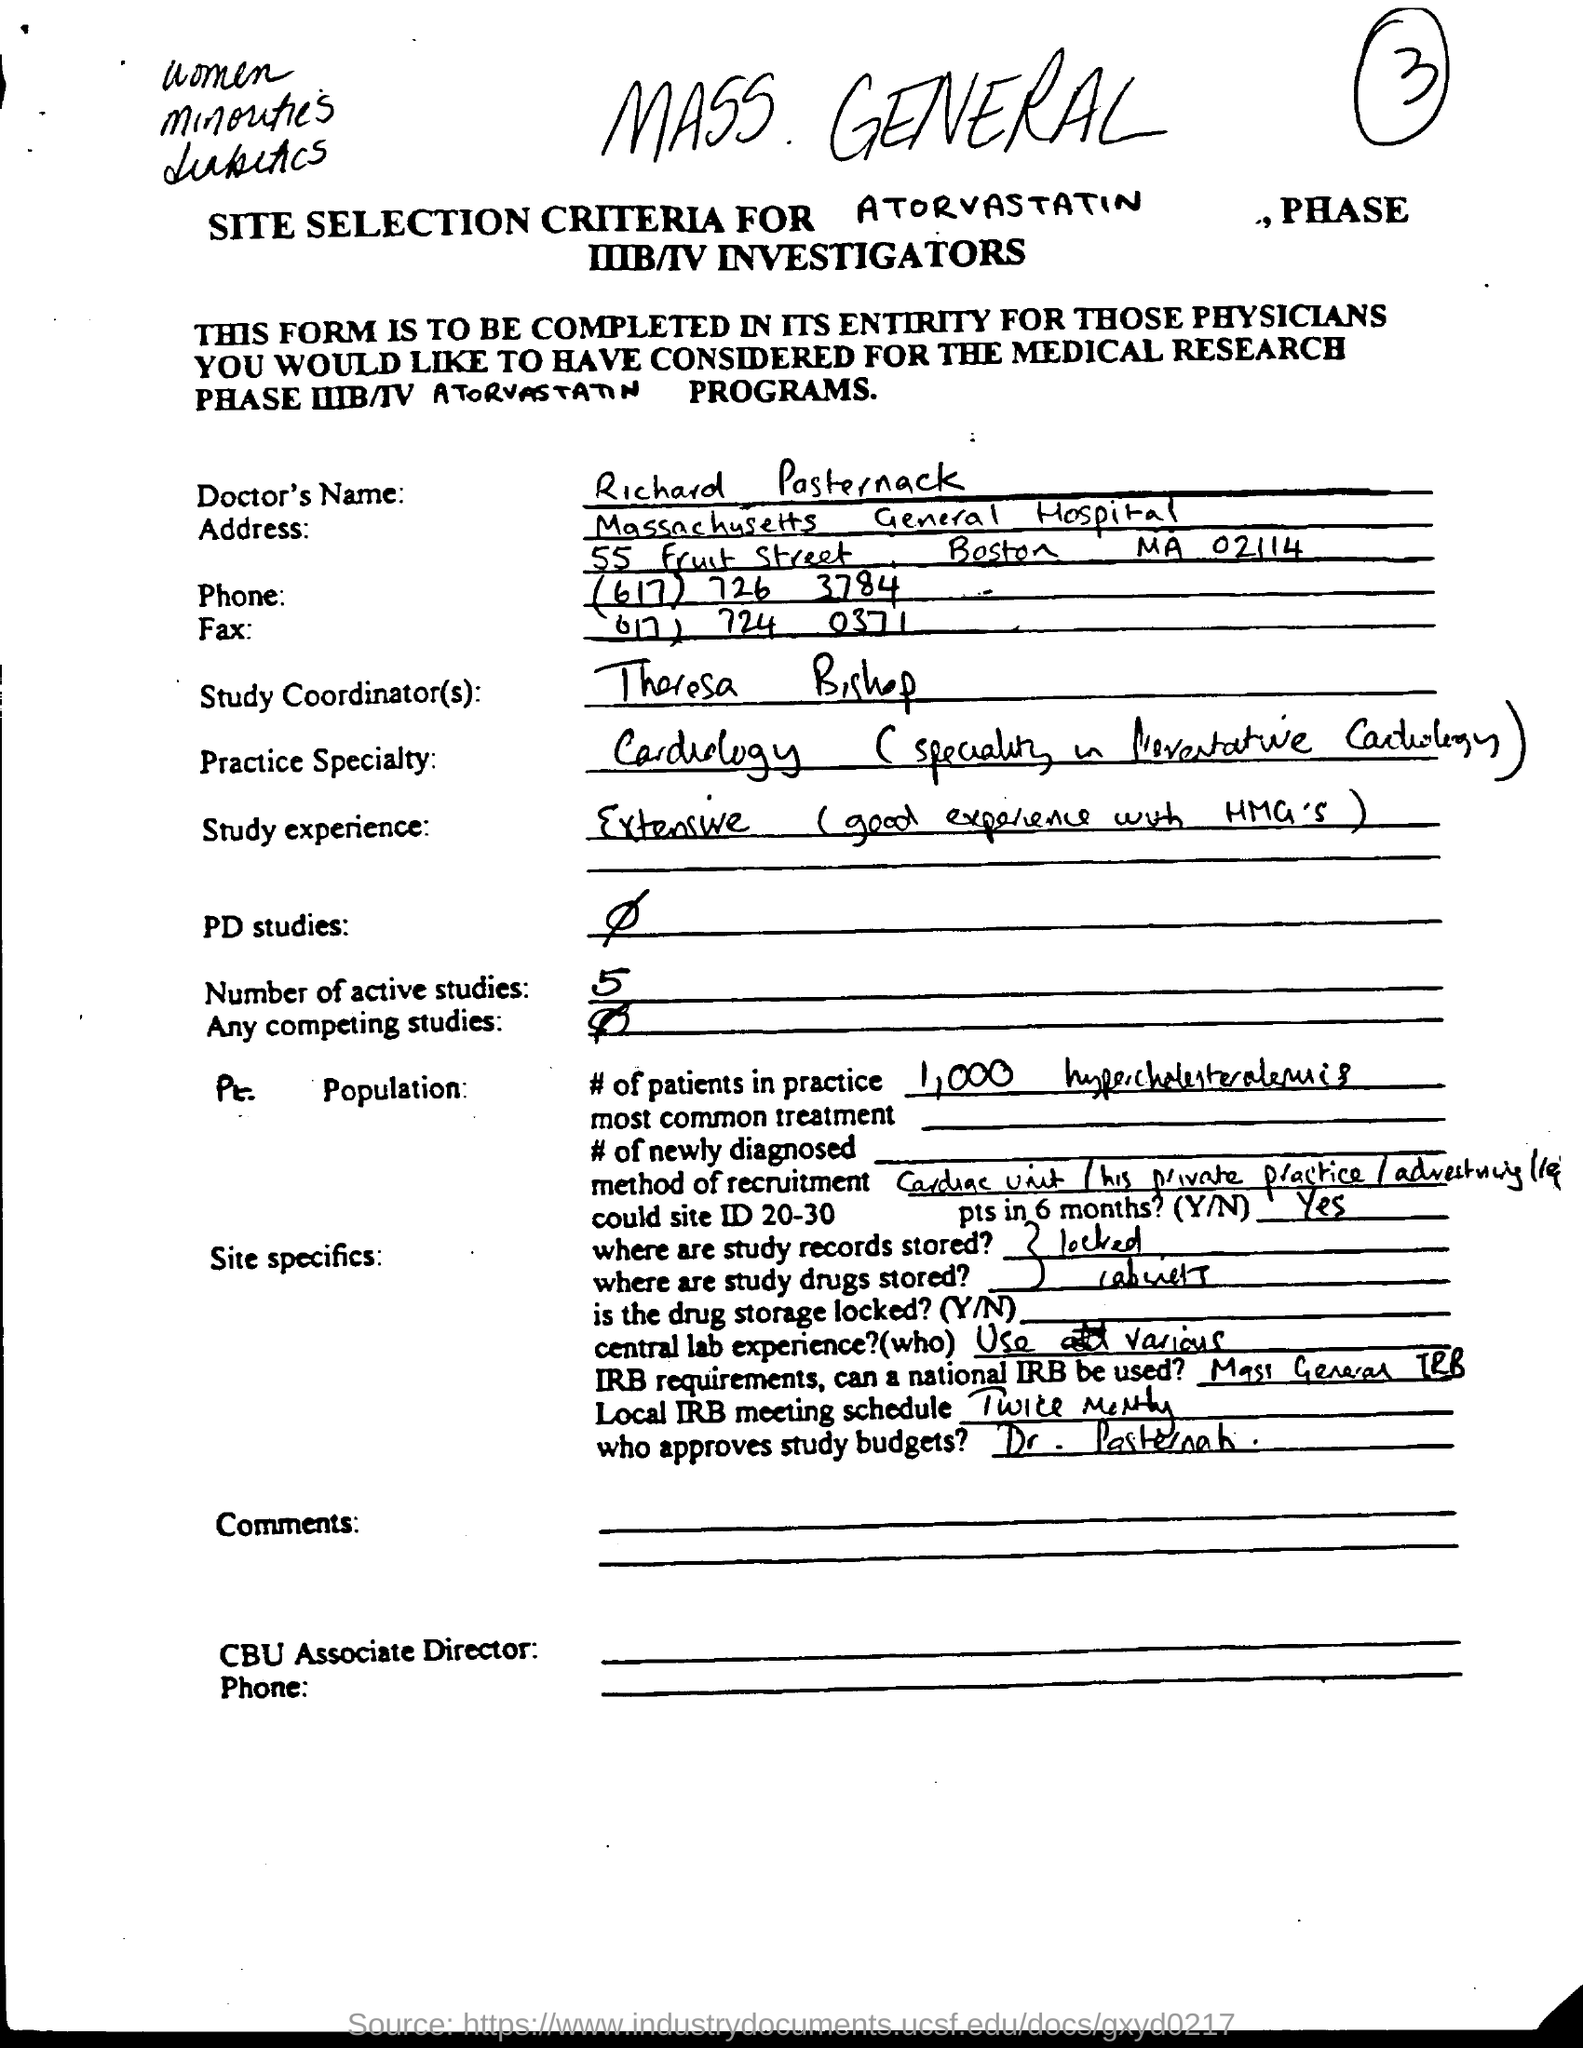What is the Doctor's Name?
Keep it short and to the point. Richard Pasternack. Who is the Study Coordinator(s)?
Offer a very short reply. Theresa Bishop. What is the number of active studies?
Provide a short and direct response. 5. 